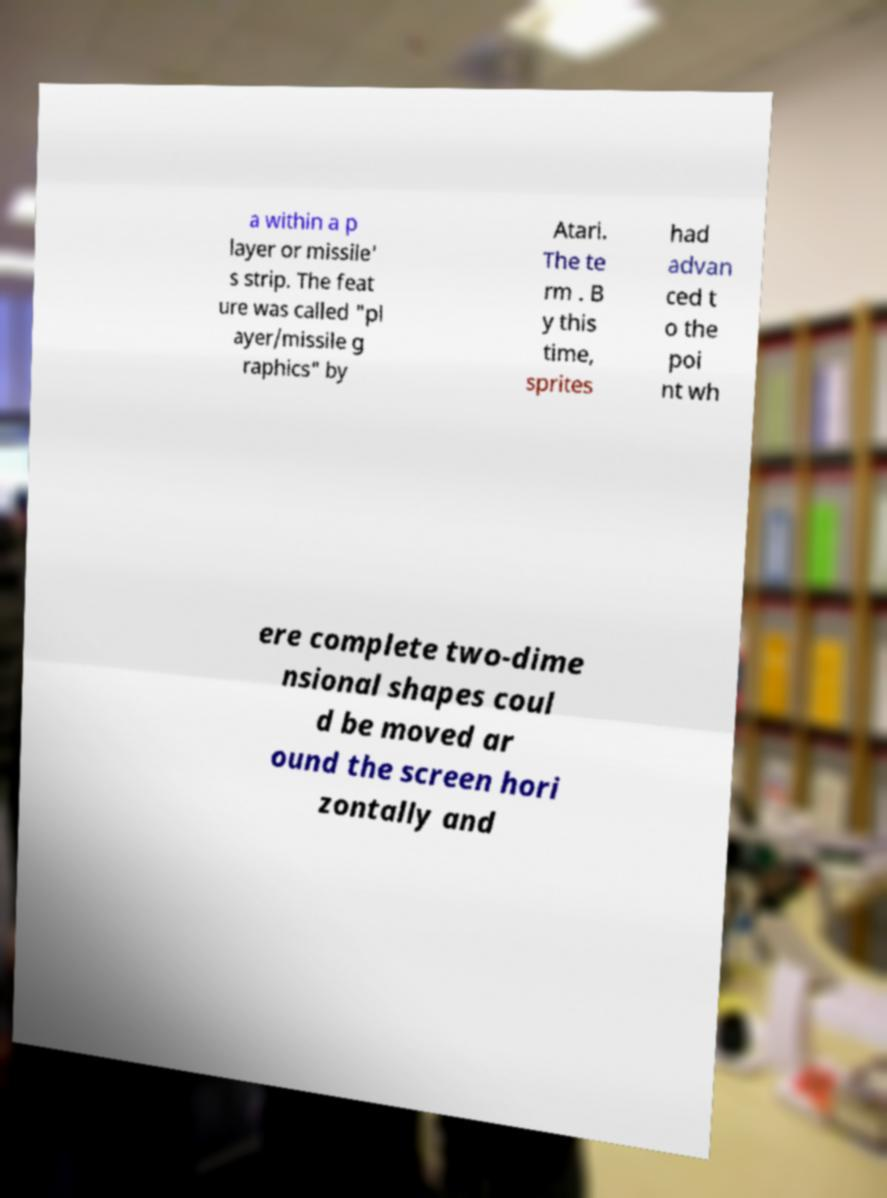What messages or text are displayed in this image? I need them in a readable, typed format. a within a p layer or missile' s strip. The feat ure was called "pl ayer/missile g raphics" by Atari. The te rm . B y this time, sprites had advan ced t o the poi nt wh ere complete two-dime nsional shapes coul d be moved ar ound the screen hori zontally and 